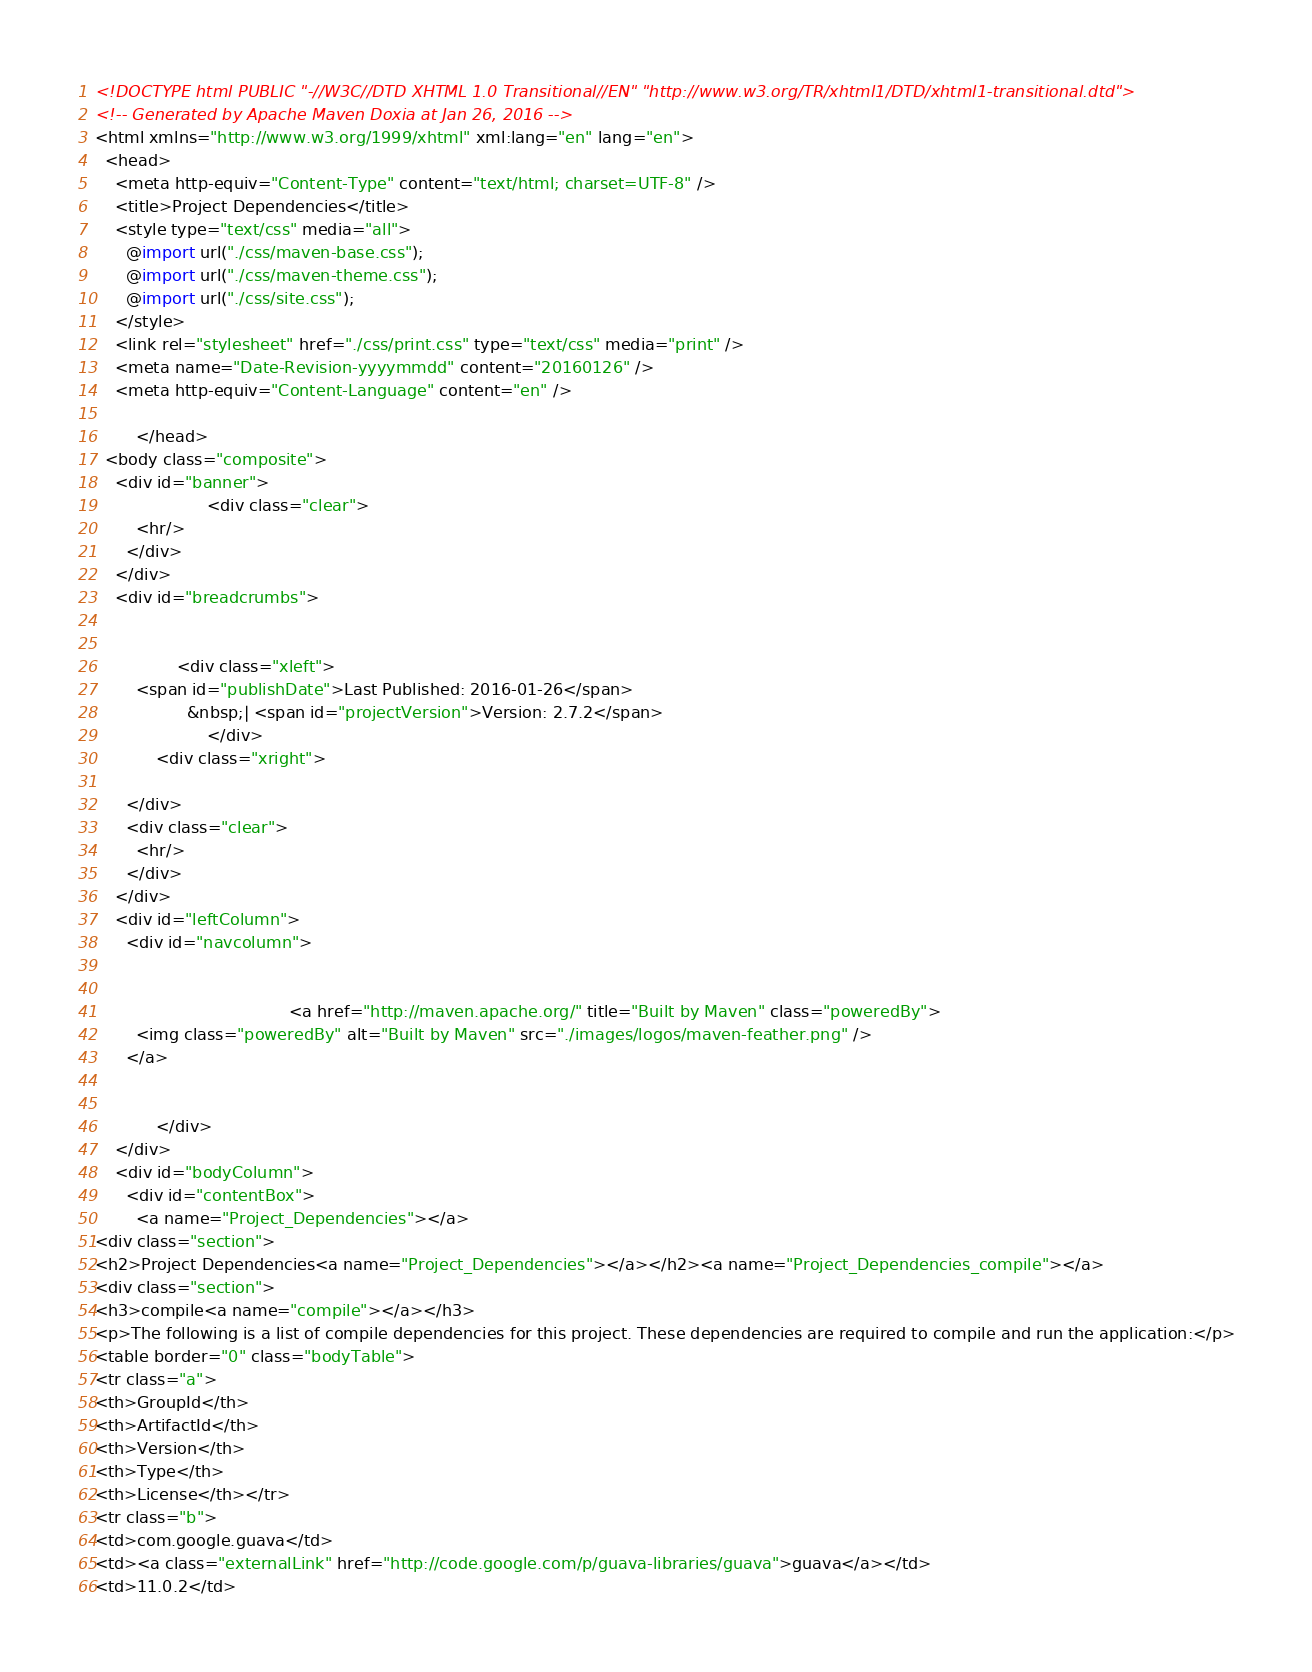Convert code to text. <code><loc_0><loc_0><loc_500><loc_500><_HTML_><!DOCTYPE html PUBLIC "-//W3C//DTD XHTML 1.0 Transitional//EN" "http://www.w3.org/TR/xhtml1/DTD/xhtml1-transitional.dtd">
<!-- Generated by Apache Maven Doxia at Jan 26, 2016 -->
<html xmlns="http://www.w3.org/1999/xhtml" xml:lang="en" lang="en">
  <head>
    <meta http-equiv="Content-Type" content="text/html; charset=UTF-8" />
    <title>Project Dependencies</title>
    <style type="text/css" media="all">
      @import url("./css/maven-base.css");
      @import url("./css/maven-theme.css");
      @import url("./css/site.css");
    </style>
    <link rel="stylesheet" href="./css/print.css" type="text/css" media="print" />
    <meta name="Date-Revision-yyyymmdd" content="20160126" />
    <meta http-equiv="Content-Language" content="en" />
        
        </head>
  <body class="composite">
    <div id="banner">
                      <div class="clear">
        <hr/>
      </div>
    </div>
    <div id="breadcrumbs">
            
        
                <div class="xleft">
        <span id="publishDate">Last Published: 2016-01-26</span>
                  &nbsp;| <span id="projectVersion">Version: 2.7.2</span>
                      </div>
            <div class="xright">        
        
      </div>
      <div class="clear">
        <hr/>
      </div>
    </div>
    <div id="leftColumn">
      <div id="navcolumn">
             
        
                                      <a href="http://maven.apache.org/" title="Built by Maven" class="poweredBy">
        <img class="poweredBy" alt="Built by Maven" src="./images/logos/maven-feather.png" />
      </a>
                   
        
            </div>
    </div>
    <div id="bodyColumn">
      <div id="contentBox">
        <a name="Project_Dependencies"></a>
<div class="section">
<h2>Project Dependencies<a name="Project_Dependencies"></a></h2><a name="Project_Dependencies_compile"></a>
<div class="section">
<h3>compile<a name="compile"></a></h3>
<p>The following is a list of compile dependencies for this project. These dependencies are required to compile and run the application:</p>
<table border="0" class="bodyTable">
<tr class="a">
<th>GroupId</th>
<th>ArtifactId</th>
<th>Version</th>
<th>Type</th>
<th>License</th></tr>
<tr class="b">
<td>com.google.guava</td>
<td><a class="externalLink" href="http://code.google.com/p/guava-libraries/guava">guava</a></td>
<td>11.0.2</td></code> 